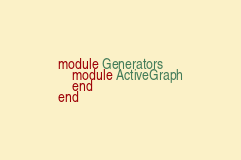<code> <loc_0><loc_0><loc_500><loc_500><_Ruby_>module Generators
	module ActiveGraph
	end
end</code> 